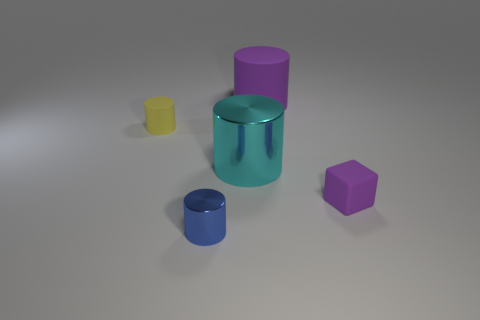What number of objects are either cylinders that are in front of the large purple cylinder or rubber objects right of the large purple matte object?
Make the answer very short. 4. Are there fewer small purple things that are on the left side of the small yellow rubber cylinder than tiny brown rubber things?
Your answer should be very brief. No. Is there a purple object of the same size as the blue cylinder?
Your response must be concise. Yes. The small metallic cylinder has what color?
Your response must be concise. Blue. Is the rubber block the same size as the cyan shiny cylinder?
Provide a succinct answer. No. How many things are tiny purple cubes or large cyan metal things?
Your answer should be very brief. 2. Are there an equal number of cyan things that are behind the large cyan object and large purple cylinders?
Your answer should be compact. No. Is there a blue thing that is behind the large purple cylinder left of the purple matte thing in front of the cyan thing?
Ensure brevity in your answer.  No. There is a tiny block that is the same material as the big purple cylinder; what is its color?
Ensure brevity in your answer.  Purple. Does the tiny object that is on the right side of the large purple rubber cylinder have the same color as the big matte thing?
Ensure brevity in your answer.  Yes. 